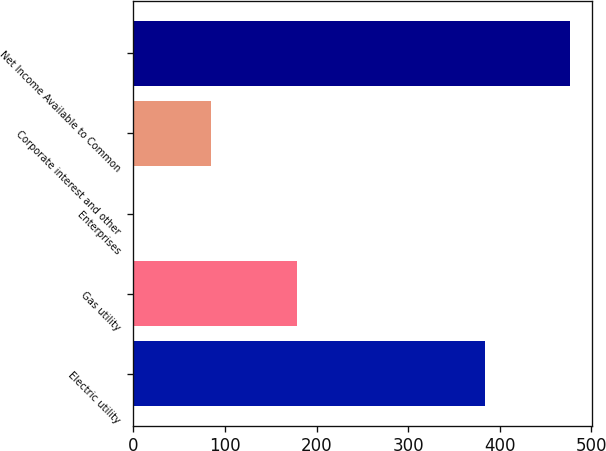Convert chart to OTSL. <chart><loc_0><loc_0><loc_500><loc_500><bar_chart><fcel>Electric utility<fcel>Gas utility<fcel>Enterprises<fcel>Corporate interest and other<fcel>Net Income Available to Common<nl><fcel>384<fcel>179<fcel>1<fcel>85<fcel>477<nl></chart> 